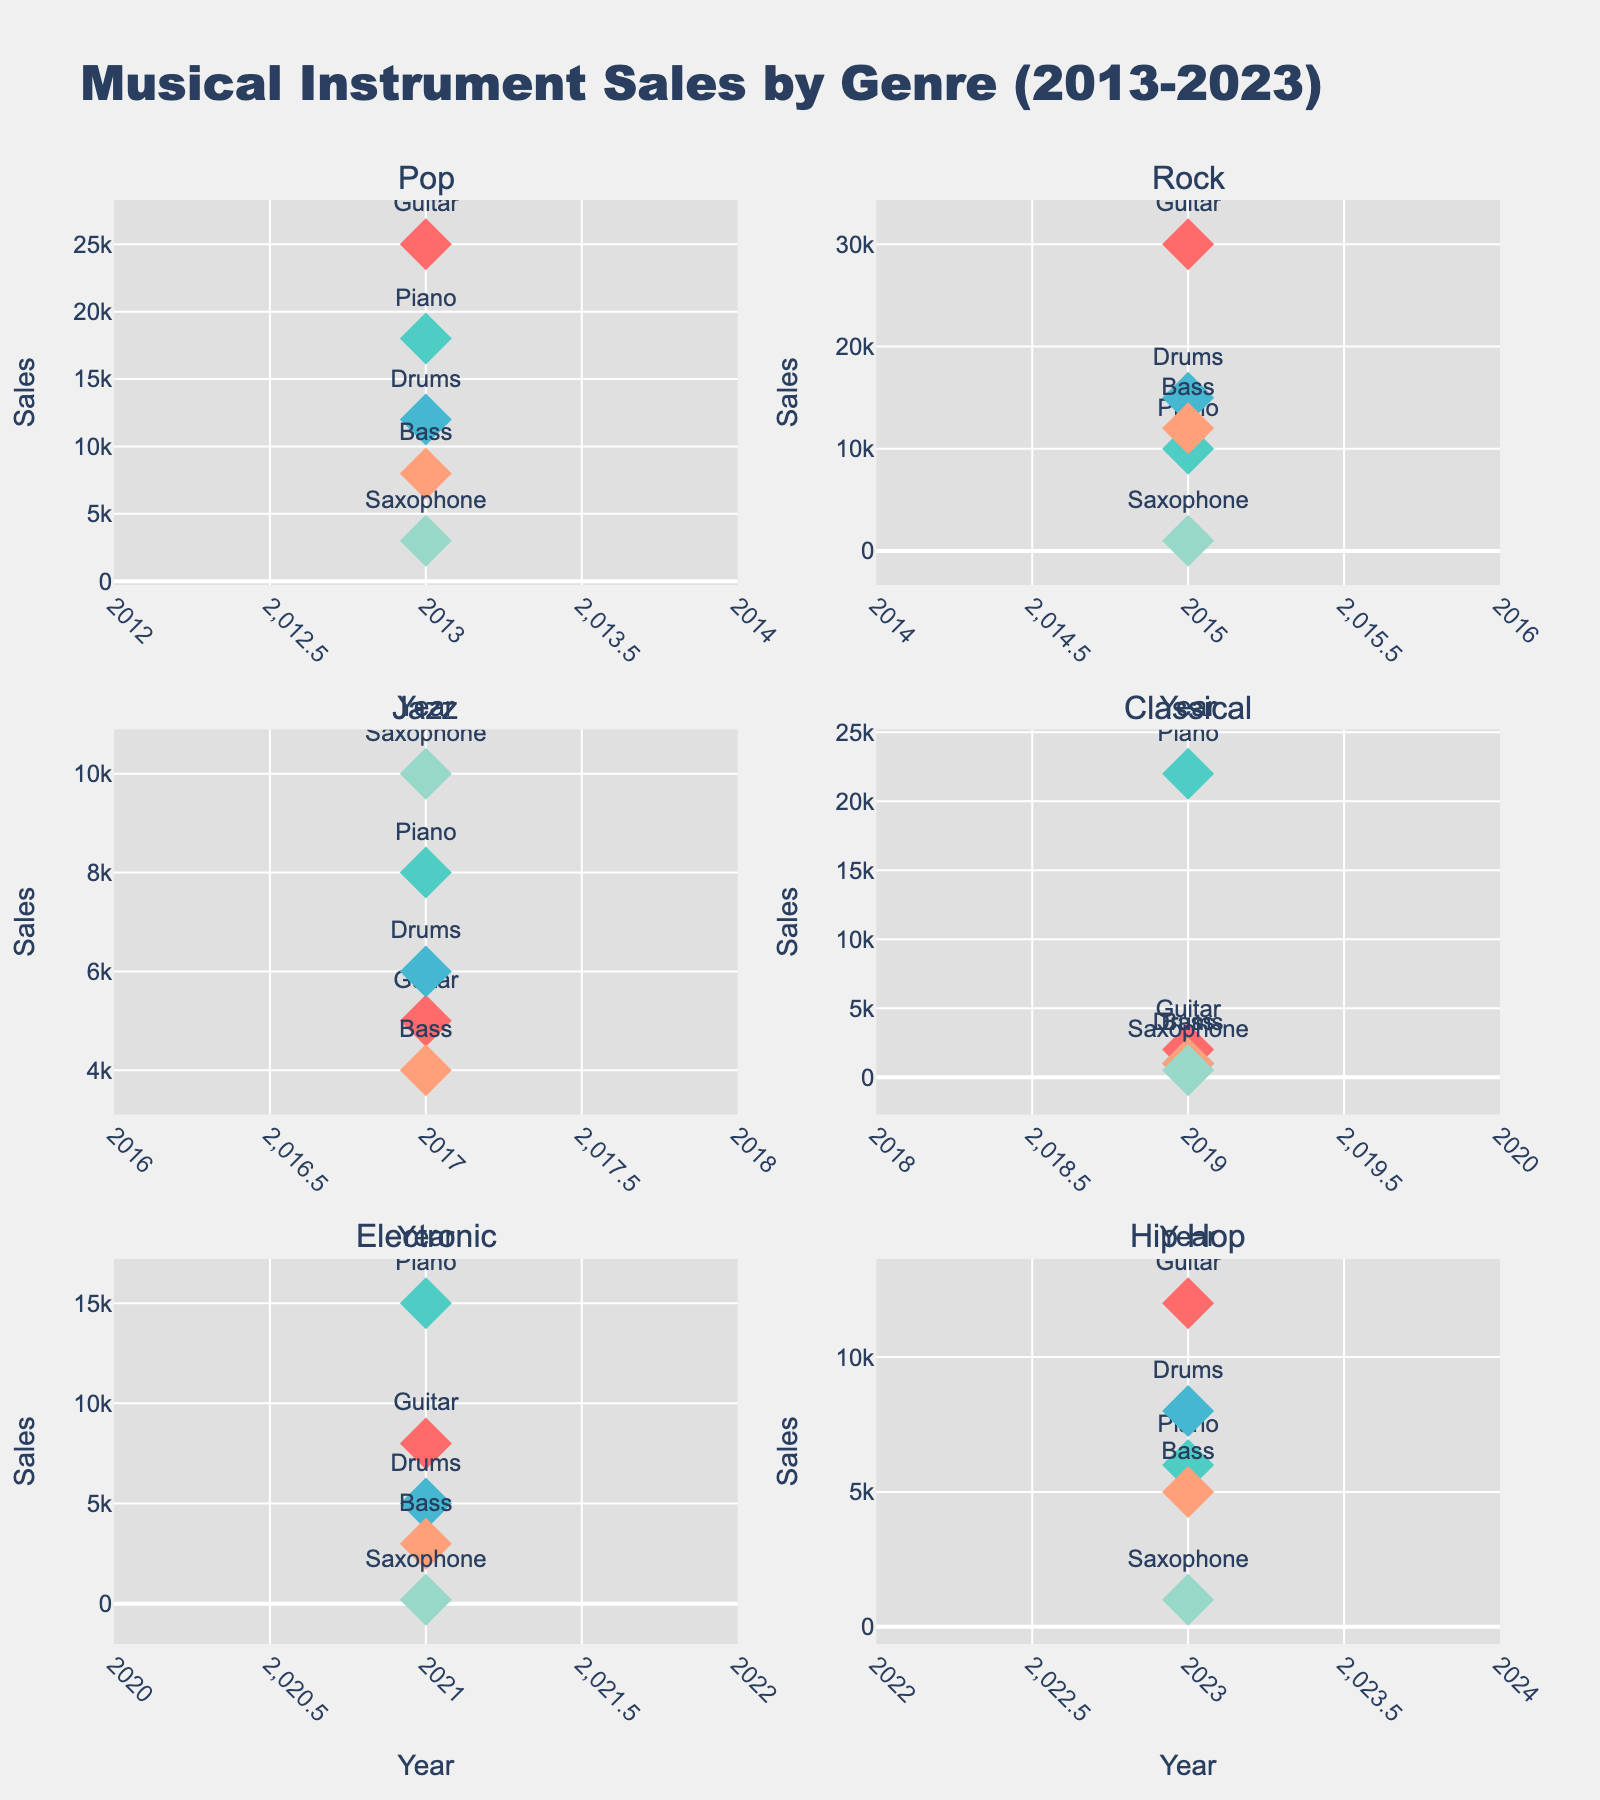What's the title of the figure? The title is found in a prominent position, typically at the top of the figure. It serves as a succinct summary of what the figure represents.
Answer: Musical Instrument Sales by Genre (2013-2023) What year had the highest guitar sales for Rock genre? To determine this, locate the Rock genre subplot and identify the data point for the guitar. The year associated with the highest value in that subplot should be selected.
Answer: 2015 Which genre had the most saxophone sales, and what was the value? To find this, you would need to compare the saxophone sales across all subplots. Identify the subplot with the highest value for saxophone sales.
Answer: Jazz, 10,000 Between Pop and Electronic genres, which one had higher piano sales and by how much? Identify the piano sales for both genres in their respective subplots. Compare the values and compute the difference.
Answer: Pop, 3,000 more In which year did Hip Hop genre have its data recorded and what are the drum sales? Check the Hip Hop subplot and note the data point indicating the year along with the value for drum sales.
Answer: 2023, 8,000 What is the total sales of bass instruments in 2023 across all genres? To find this, look at the sales data for bass instruments across all subplots noting the year 2023, then sum these values to get the total. Only Hip Hop has a value for bass in 2023 as per the data.
Answer: 5,000 Which genre had the lowest overall musical instrument sales and how can it be determined from the figure? To determine the genre with the lowest overall sales, add the sales for each instrument in each genre and compare the totals. The genre with the smallest sum has the lowest sales.
Answer: Classical What's the average sales of drums across all genres? Extract the drum sales for each genre from the subplots, sum these values, and divide by the number of genres (6 in this case) to compute the average.
Answer: 8,500 Are there any genres where piano sales exceed guitar sales? If so, which ones? Compare piano and guitar sales within each genre's subplot to see if piano sales are higher for any genre.
Answer: Classical, Electronic How do the bass sales in Rock genre compare to those in Hip Hop genre? Locate the bass sales in the Rock and Hip Hop subplots and directly compare the values.
Answer: Rock has higher bass sales than Hip Hop 